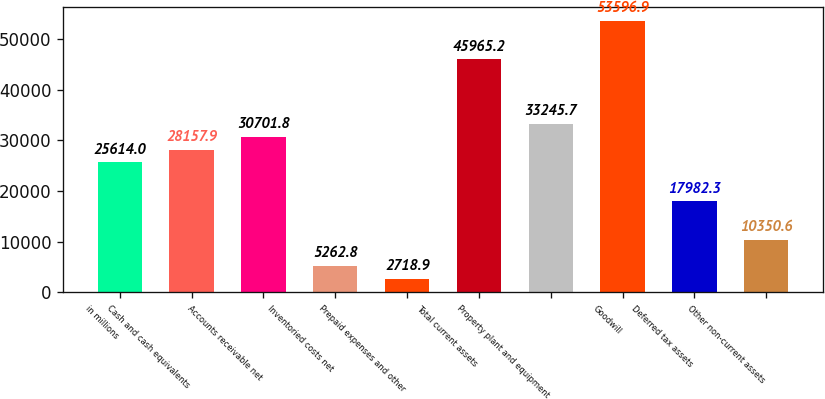<chart> <loc_0><loc_0><loc_500><loc_500><bar_chart><fcel>in millions<fcel>Cash and cash equivalents<fcel>Accounts receivable net<fcel>Inventoried costs net<fcel>Prepaid expenses and other<fcel>Total current assets<fcel>Property plant and equipment<fcel>Goodwill<fcel>Deferred tax assets<fcel>Other non-current assets<nl><fcel>25614<fcel>28157.9<fcel>30701.8<fcel>5262.8<fcel>2718.9<fcel>45965.2<fcel>33245.7<fcel>53596.9<fcel>17982.3<fcel>10350.6<nl></chart> 